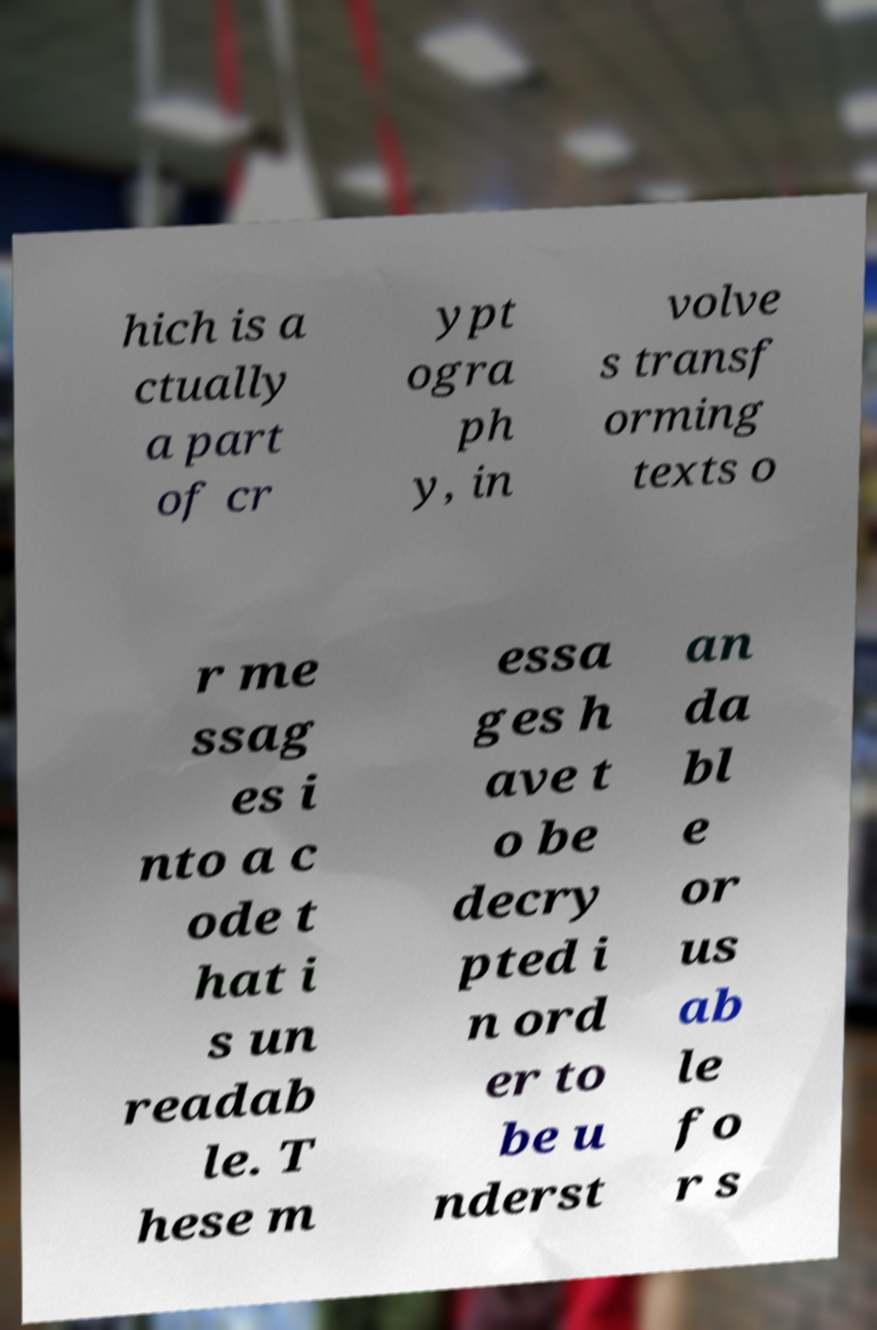I need the written content from this picture converted into text. Can you do that? hich is a ctually a part of cr ypt ogra ph y, in volve s transf orming texts o r me ssag es i nto a c ode t hat i s un readab le. T hese m essa ges h ave t o be decry pted i n ord er to be u nderst an da bl e or us ab le fo r s 